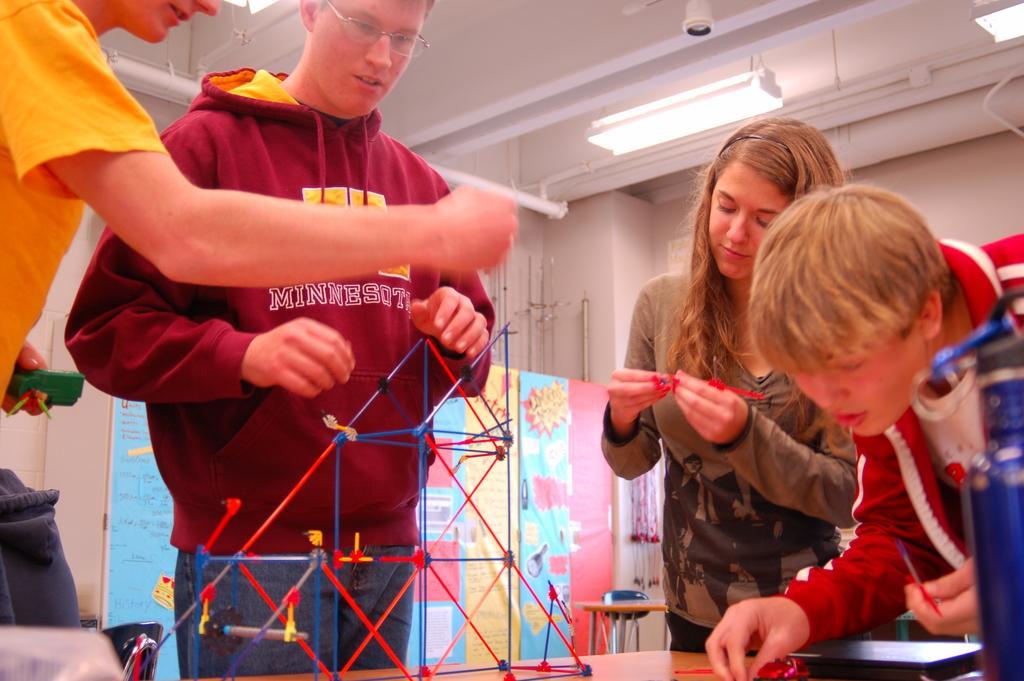Could you give a brief overview of what you see in this image? In this picture there are people those who are standing around the table, they are arranging a model of a triangle, with the help of sticks and there are lamps on the roof at the top side of the image, there are posters in the background area of the image. 